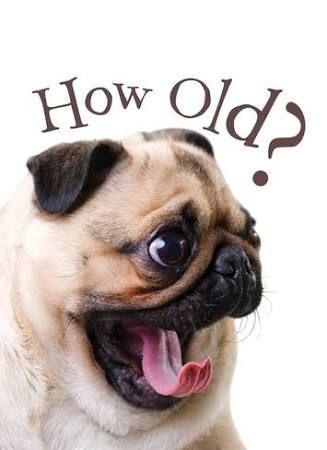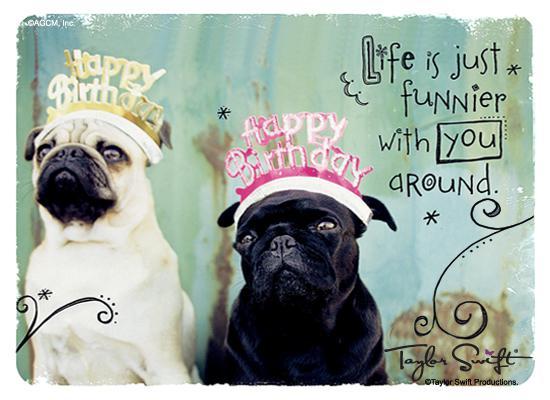The first image is the image on the left, the second image is the image on the right. For the images displayed, is the sentence "One of the dogs is lying down." factually correct? Answer yes or no. No. The first image is the image on the left, the second image is the image on the right. Examine the images to the left and right. Is the description "One image shows a buff-beige pug with its head turned to the side and its tongue sticking out." accurate? Answer yes or no. Yes. 